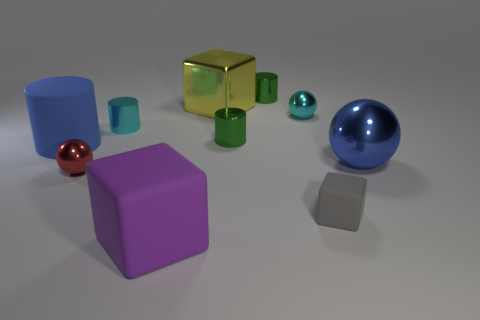What material is the sphere that is behind the blue thing that is to the right of the large metallic thing that is on the left side of the tiny gray block?
Provide a succinct answer. Metal. Are there any blue metallic things of the same size as the yellow thing?
Make the answer very short. Yes. What shape is the blue rubber thing?
Your answer should be very brief. Cylinder. How many cylinders are either green metallic objects or gray things?
Offer a terse response. 2. Is the number of blocks that are to the right of the tiny red metal sphere the same as the number of small gray rubber blocks behind the large shiny cube?
Give a very brief answer. No. There is a blue thing that is on the left side of the yellow shiny object that is to the right of the blue rubber object; how many cyan shiny cylinders are in front of it?
Ensure brevity in your answer.  0. What is the shape of the object that is the same color as the large cylinder?
Provide a short and direct response. Sphere. Does the large shiny cube have the same color as the ball on the left side of the large yellow shiny cube?
Ensure brevity in your answer.  No. Is the number of small shiny cylinders that are in front of the gray cube greater than the number of large blue shiny balls?
Give a very brief answer. No. How many objects are blue objects right of the red metallic thing or big things that are behind the tiny gray cube?
Your response must be concise. 3. 